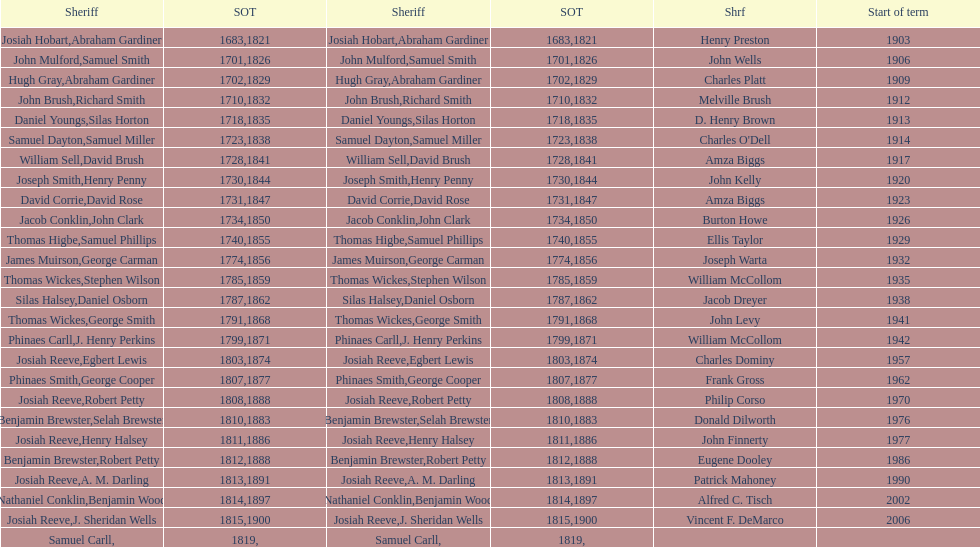Which sheriff came before thomas wickes? James Muirson. 